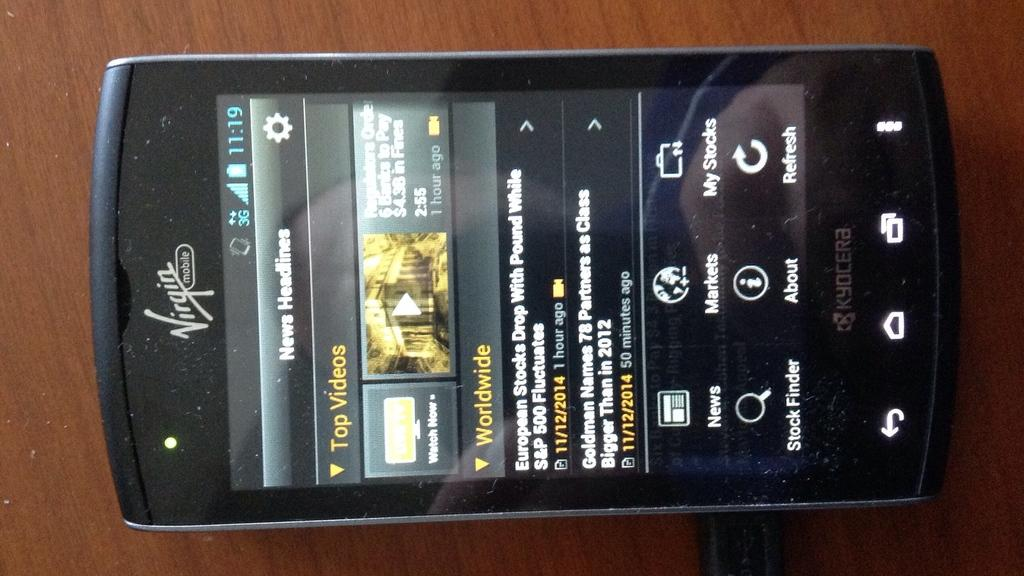<image>
Give a short and clear explanation of the subsequent image. The front screen of a virgin mobile cell phone that's browsing new releases of movies. 